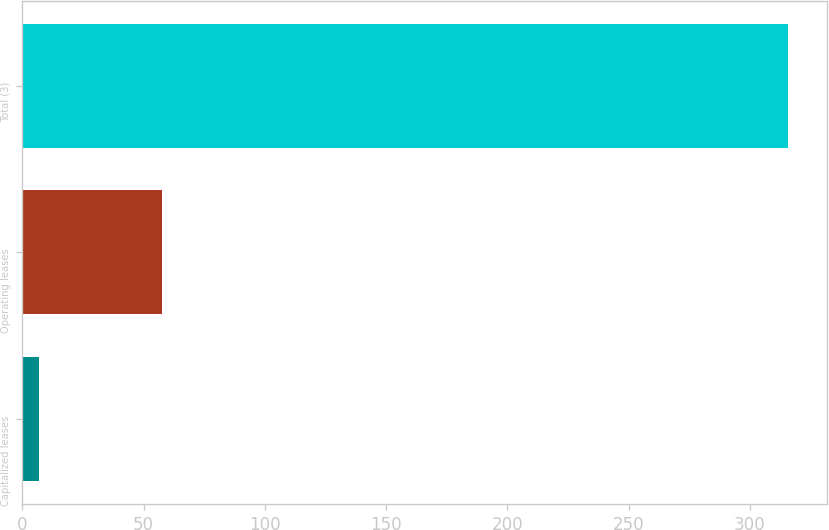<chart> <loc_0><loc_0><loc_500><loc_500><bar_chart><fcel>Capitalized leases<fcel>Operating leases<fcel>Total (3)<nl><fcel>6.7<fcel>57.4<fcel>315.9<nl></chart> 